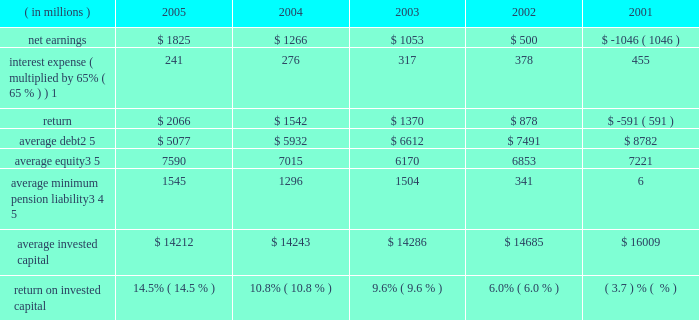Page 74 notes to five year summary ( a ) includes the effects of items not considered in senior management 2019s assessment of the operating performance of the corporation 2019s business segments ( see the section , 201cresults of operations 201d in management 2019s discussion and analysis of financial condition and results of operations ( md&a ) ) which , on a combined basis , increased earnings from continuing operations before income taxes by $ 173 million , $ 113 million after tax ( $ 0.25 per share ) .
( b ) includes the effects of items not considered in senior management 2019s assessment of the operating performance of the corporation 2019s business segments ( see the section , 201cresults of operations 201d in md&a ) which , on a combined basis , decreased earnings from continuing operations before income taxes by $ 215 million , $ 154 million after tax ( $ 0.34 per share ) .
Also includes a reduction in income tax expense resulting from the closure of an internal revenue service examination of $ 144 million ( $ 0.32 per share ) .
These items reduced earnings by $ 10 million after tax ( $ 0.02 per share ) .
( c ) includes the effects of items not considered in senior management 2019s assessment of the operating performance of the corporation 2019s business segments ( see the section , 201cresults of operations 201d in md&a ) which , on a combined basis , decreased earnings from continuing operations before income taxes by $ 153 million , $ 102 million after tax ( $ 0.22 per share ) .
( d ) includes the effects of items not considered in senior management 2019s assessment of the operating performance of the corporation 2019s business segments which , on a combined basis , decreased earnings from continuing operations before income taxes by $ 1112 million , $ 632 million after tax ( $ 1.40 per share ) .
In 2002 , the corporation adopted fas 142 which prohibits the amortization of goodwill .
( e ) includes the effects of items not considered in senior management 2019s assessment of the operating performance of the corporation 2019s business segments which , on a combined basis , decreased earnings from continuing operations before income taxes by $ 973 million , $ 651 million after tax ( $ 1.50 per share ) .
Also includes a gain from the disposal of a business and charges for the corporation 2019s exit from its global telecommunications services business which is included in discontinued operations and which , on a combined basis , increased the net loss by $ 1 billion ( $ 2.38 per share ) .
( f ) the corporation defines return on invested capital ( roic ) as net income plus after-tax interest expense divided by average invested capital ( stockholders 2019 equity plus debt ) , after adjusting stockholders 2019 equity by adding back the minimum pension liability .
The adjustment to add back the minimum pension liability is a revision to our calculation in 2005 , which the corporation believes more closely links roic to management performance .
Further , the corporation believes that reporting roic provides investors with greater visibility into how effectively lockheed martin uses the capital invested in its operations .
The corporation uses roic to evaluate multi-year investment decisions and as a long-term performance measure , and also uses roic as a factor in evaluating management performance under certain incentive compensation plans .
Roic is not a measure of financial performance under gaap , and may not be defined and calculated by other companies in the same manner .
Roic should not be considered in isola- tion or as an alternative to net earnings as an indicator of performance .
The following calculations of roic reflect the revision to the calculation discussed above for all periods presented .
( in millions ) 2005 2004 2003 2002 2001 .
1 represents after-tax interest expense utilizing the federal statutory rate of 35% ( 35 % ) .
2 debt consists of long-term debt , including current maturities , and short-term borrowings ( if any ) .
3 equity includes non-cash adjustments for other comprehensive losses , primarily for the additional minimum pension liability .
4 minimum pension liability values reflect the cumulative value of entries identified in our statement of stockholders equity under the caption 201cminimum pension liability . 201d the annual minimum pension liability adjustments to equity were : 2001 = ( $ 33 million ) ; 2002 = ( $ 1537 million ) ; 2003 = $ 331 million ; 2004 = ( $ 285 million ) ; 2005 = ( $ 105 million ) .
As these entries are recorded in the fourth quarter , the value added back to our average equity in a given year is the cumulative impact of all prior year entries plus 20% ( 20 % ) of the cur- rent year entry value .
5 yearly averages are calculated using balances at the start of the year and at the end of each quarter .
Lockheed martin corporation .
What was the percentage of the taxes based on the based on the earnings from continuing operations before and after tax in the md&a? 
Computations: ((173 - 113) / 173)
Answer: 0.34682. 